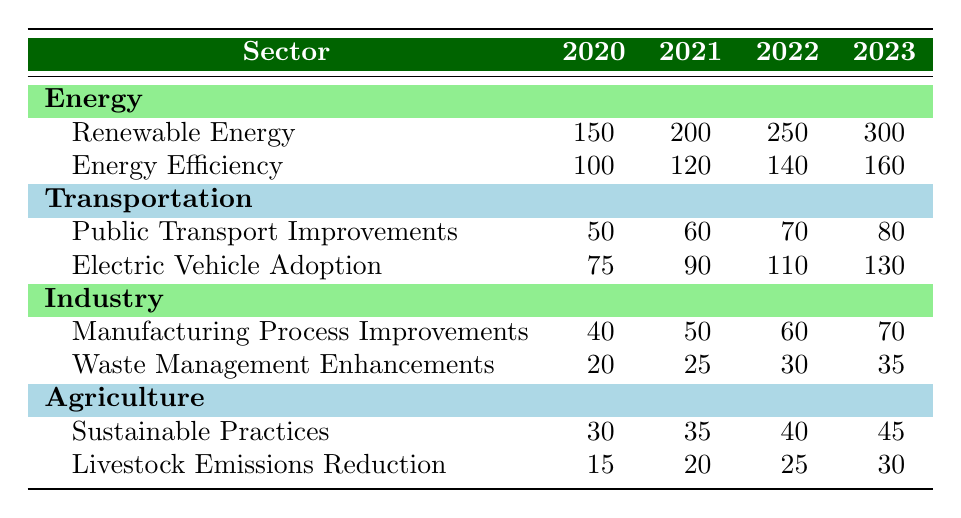What was the carbon emission reduction in Renewable Energy in 2021? The table shows that the value for Renewable Energy in 2021 is 200.
Answer: 200 Which sector saw the greatest increase in carbon emission reductions from 2020 to 2023? To find the sector with the greatest increase, we calculate the differences for each sector: Energy: (300 - 150) = 150; Transportation: (130 - 75) = 55; Industry: (70 - 40) = 30; Agriculture: (45 - 30) = 15. The greatest increase is in Energy with 150.
Answer: Energy Is the total carbon emission reduction from the Agriculture sector higher in 2022 than in 2021? For Agriculture in 2022, the total is (40 + 25) = 65, and in 2021 it is (35 + 20) = 55. Since 65 is greater than 55, the statement is true.
Answer: Yes What is the average carbon emission reduction in the Industry sector from 2020 to 2023? The values for the Industry sector are: 40, 50, 60, and 70. The sum is (40 + 50 + 60 + 70) = 220, and the average is 220/4 = 55.
Answer: 55 Did the Public Transport Improvements contribute more to carbon emission reductions than Sustainable Practices in 2020? In 2020, Public Transport Improvements had a value of 50, while Sustainable Practices had a value of 30. Comparing the two values, 50 is greater than 30, so the statement is true.
Answer: Yes What is the total carbon emission reduction across all sectors in 2023? We calculate the total for 2023 by summing all the reductions: (300 + 160) + (80 + 130) + (70 + 35) + (45 + 30) = 300 + 160 + 80 + 130 + 70 + 35 + 45 + 30 = 850.
Answer: 850 Which sector had the least carbon emission reduction in 2020? In 2020, we look at the values: Energy (150 + 100), Transportation (50 + 75), Industry (40 + 20), Agriculture (30 + 15). The totals are: Energy 250, Transportation 125, Industry 60, Agriculture 45. The least is in Industry with 60.
Answer: Industry How much did the carbon emission reductions from Electric Vehicle Adoption increase from 2021 to 2023? The value for Electric Vehicle Adoption in 2021 is 90 and in 2023 is 130. The increase is 130 - 90 = 40.
Answer: 40 What was the total carbon emission reduction for Energy in 2022? For Energy in 2022, we sum the values: 250 (Renewable Energy) + 140 (Energy Efficiency) = 390.
Answer: 390 